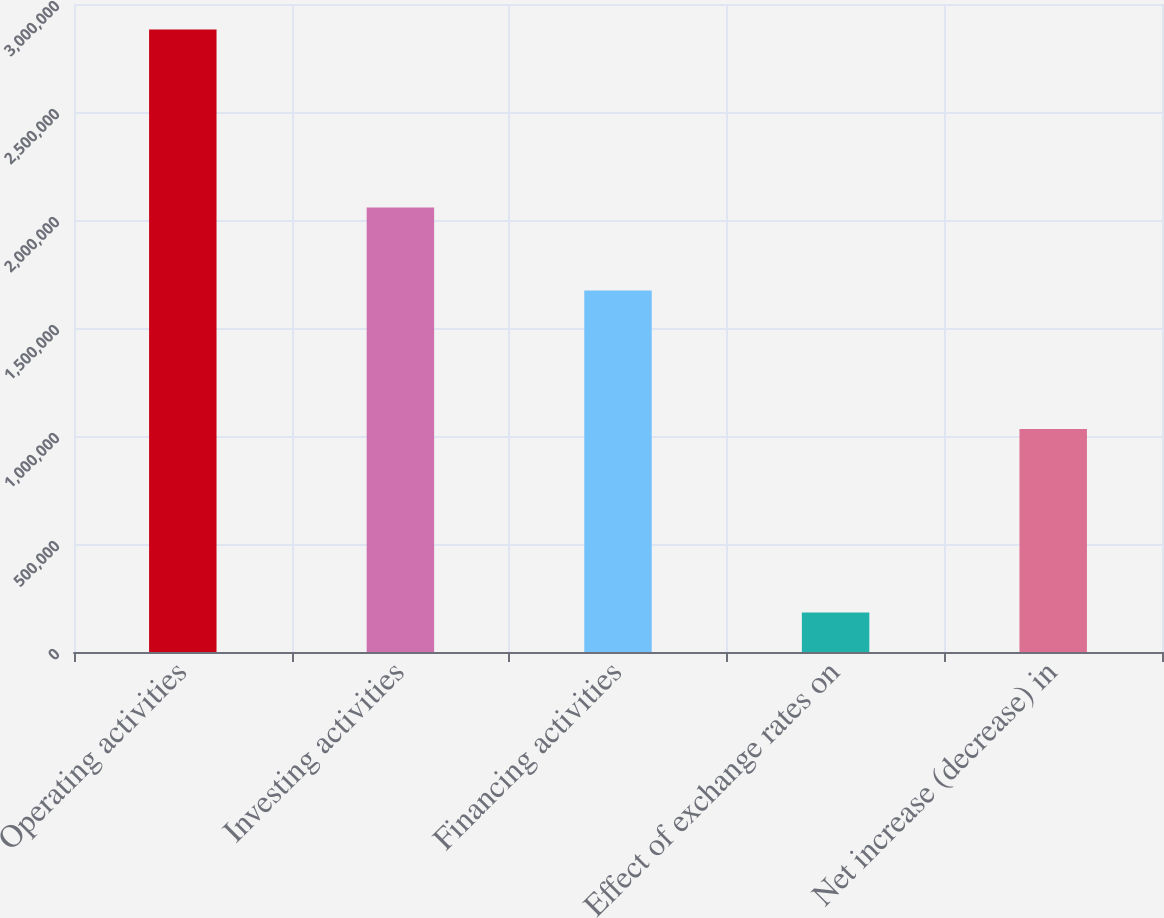<chart> <loc_0><loc_0><loc_500><loc_500><bar_chart><fcel>Operating activities<fcel>Investing activities<fcel>Financing activities<fcel>Effect of exchange rates on<fcel>Net increase (decrease) in<nl><fcel>2.882e+06<fcel>2.05735e+06<fcel>1.67385e+06<fcel>183061<fcel>1.03226e+06<nl></chart> 